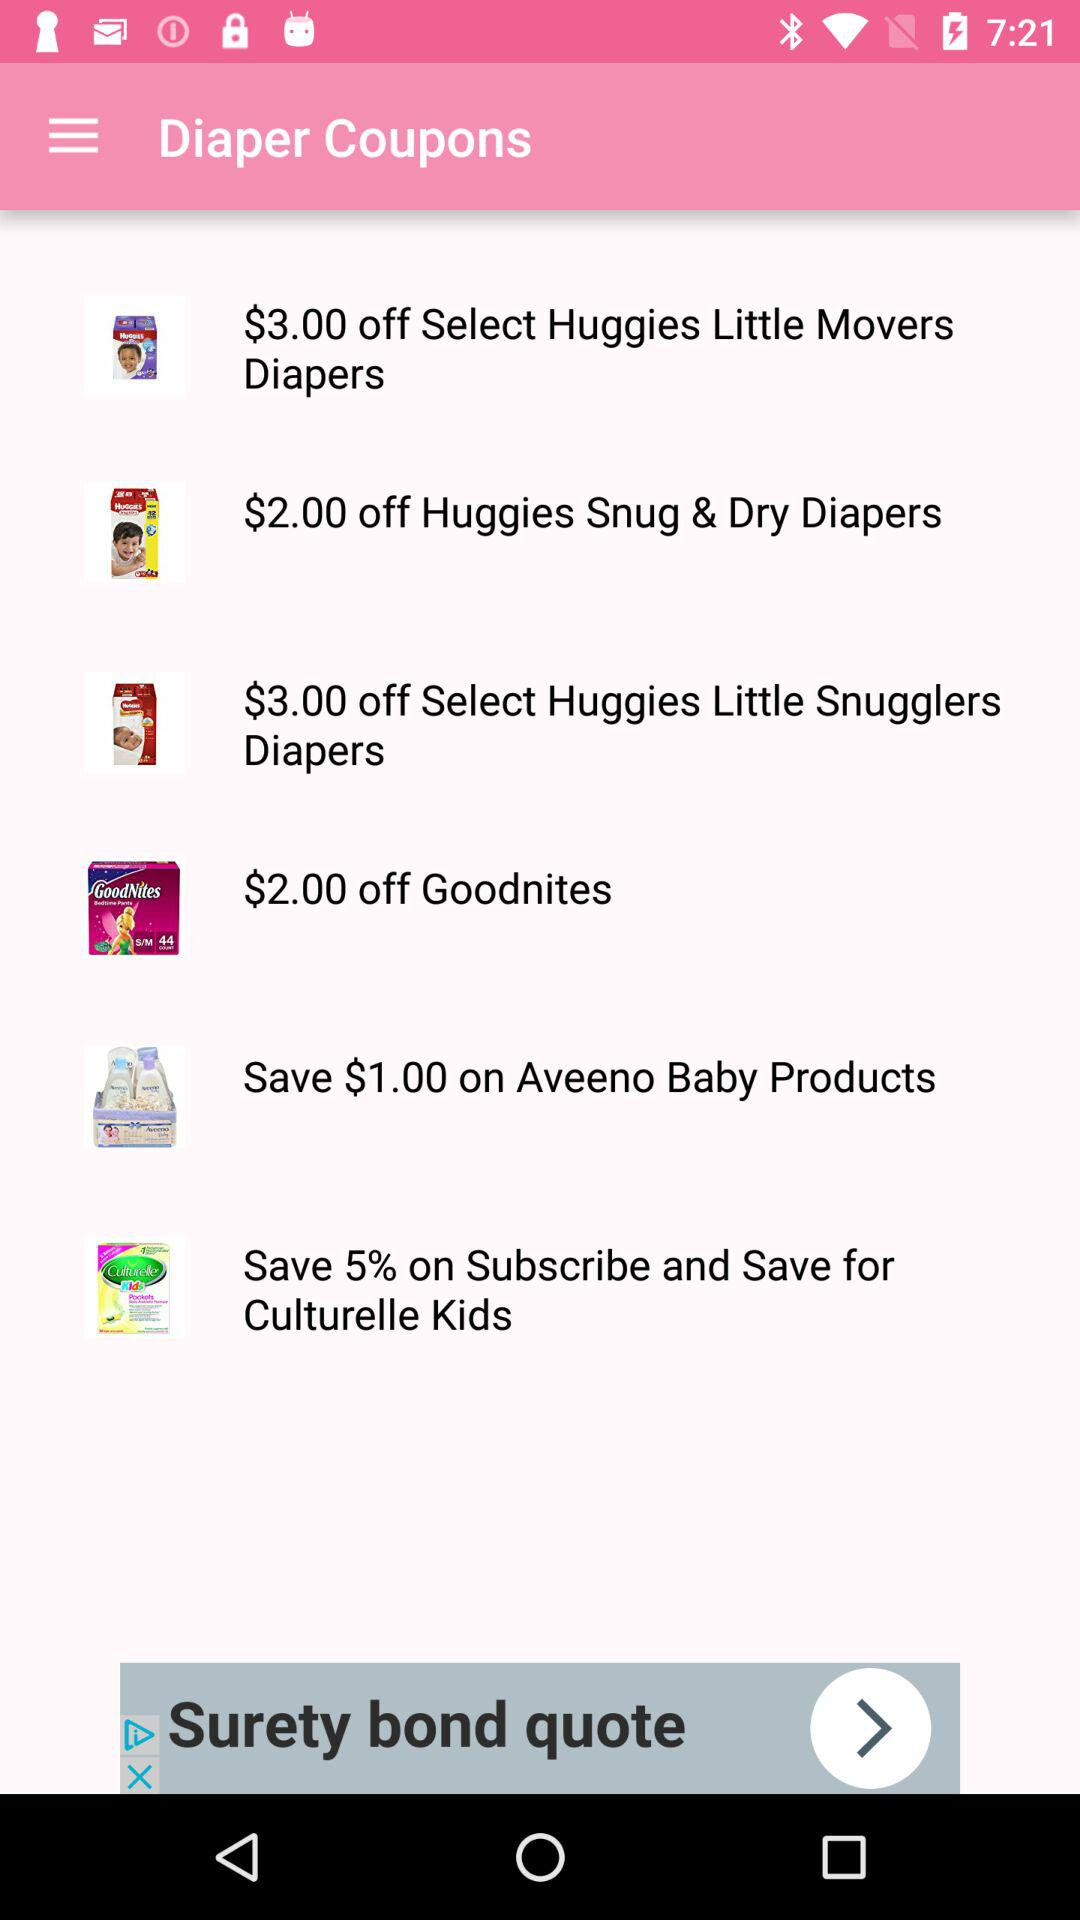How many more coupons are for Huggies products than Aveeno products?
Answer the question using a single word or phrase. 2 